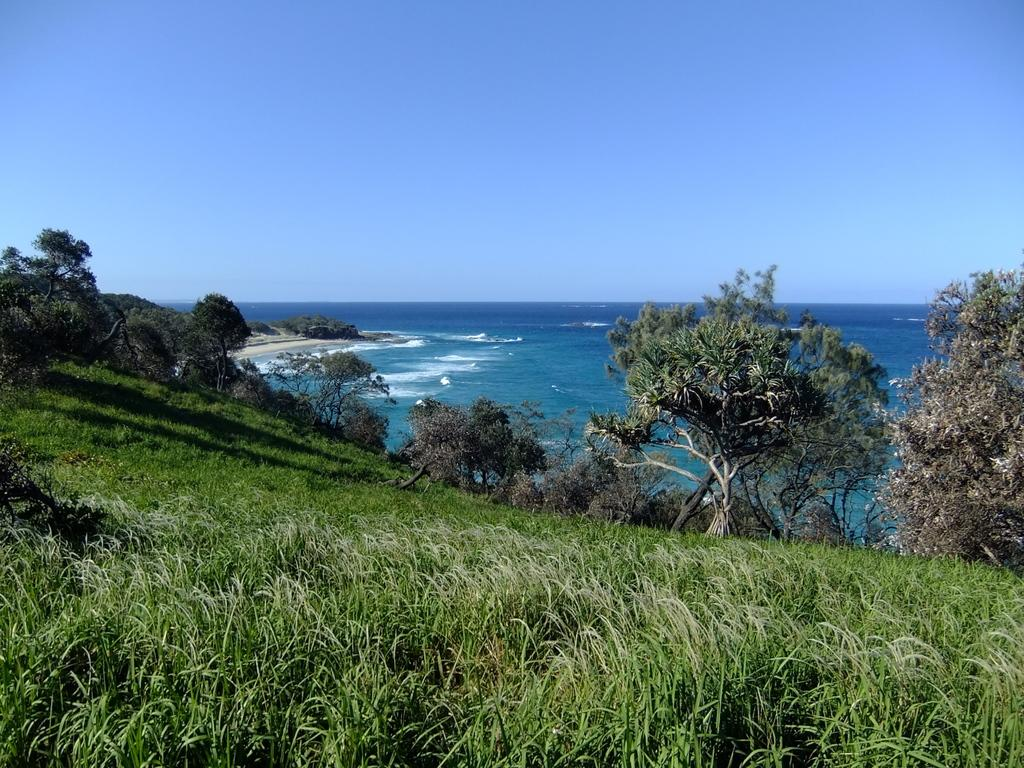What is the main feature of the image? There is an ocean in the image. What type of vegetation can be seen at the bottom of the image? Trees are present at the bottom of the image. What type of terrain is visible in the image? Grassy land is visible in the image. Can you hear the mice crying in the image? There are no mice or sounds present in the image, so it is not possible to hear any crying. 